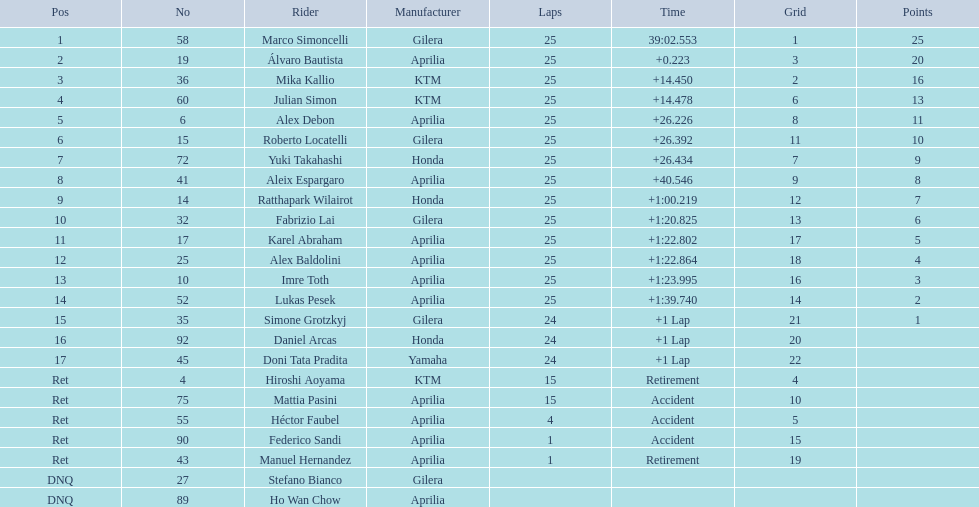How many times did hiroshi aoyama go around the track? 15. How many times did marco simoncelli go around the track? 25. Who had a greater number of laps between hiroshi aoyama and marco simoncelli? Marco Simoncelli. 